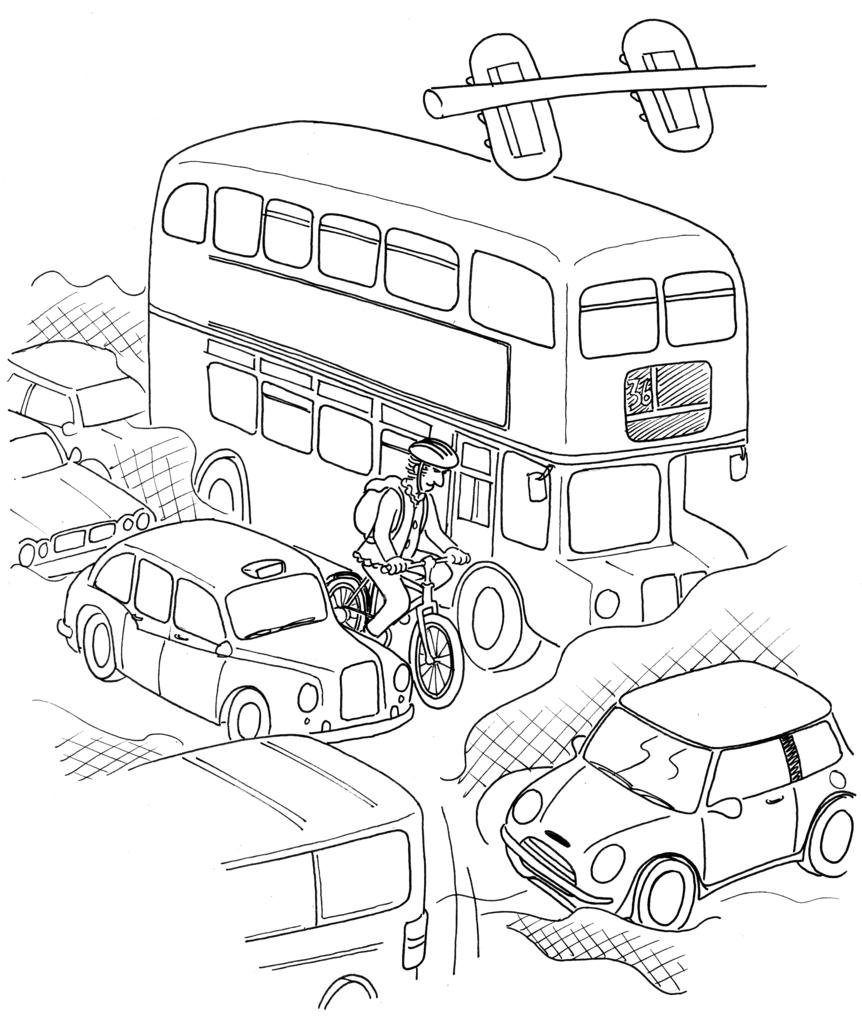What is the main subject of the sketch in the image? The main subject of the sketch in the image is vehicles. Is there any human presence in the sketch? Yes, there is a person in the sketch. What is the person wearing in the sketch? The person is wearing a bag in the sketch. What is the person doing in the sketch? The person is sitting on a bicyclearly visible in the image. What type of watch is the person wearing in the sketch? There is no watch visible in the sketch; the person is wearing a bag. Is there a stage present in the sketch? There is no stage present in the sketch; it contains a sketch of vehicles and a person sitting on a bicycle. 